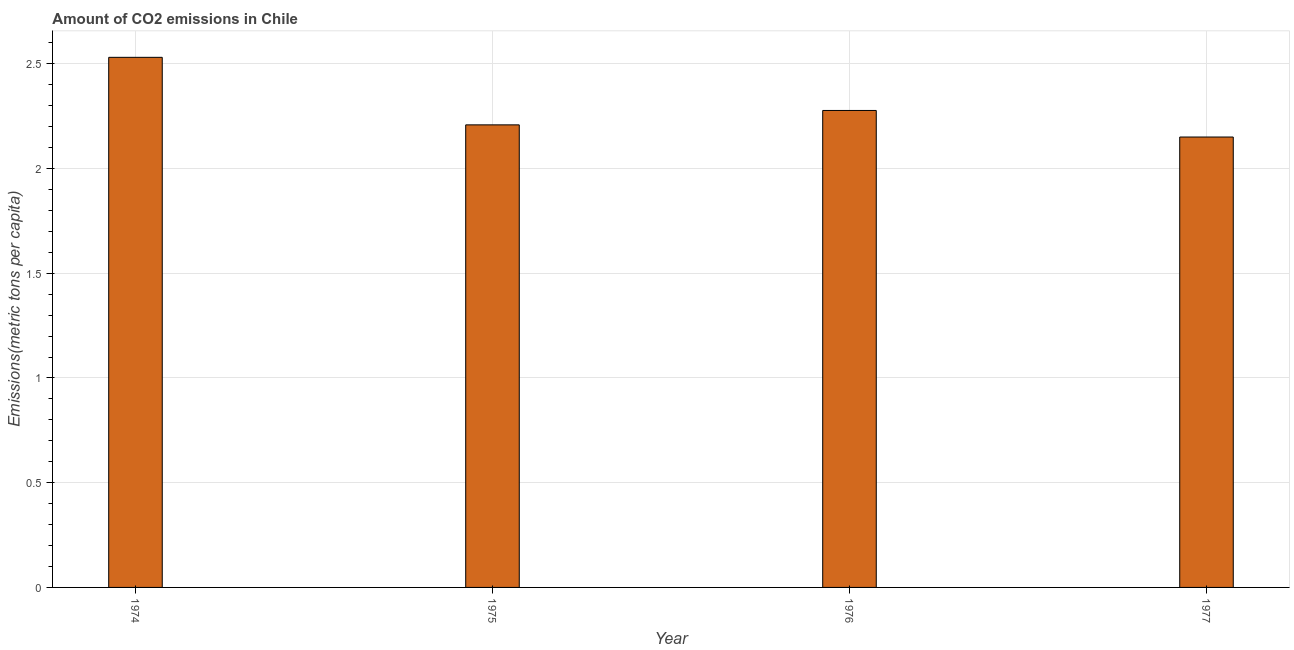Does the graph contain any zero values?
Offer a very short reply. No. What is the title of the graph?
Your response must be concise. Amount of CO2 emissions in Chile. What is the label or title of the Y-axis?
Keep it short and to the point. Emissions(metric tons per capita). What is the amount of co2 emissions in 1974?
Provide a succinct answer. 2.53. Across all years, what is the maximum amount of co2 emissions?
Your response must be concise. 2.53. Across all years, what is the minimum amount of co2 emissions?
Make the answer very short. 2.15. In which year was the amount of co2 emissions maximum?
Ensure brevity in your answer.  1974. In which year was the amount of co2 emissions minimum?
Provide a succinct answer. 1977. What is the sum of the amount of co2 emissions?
Provide a short and direct response. 9.17. What is the difference between the amount of co2 emissions in 1975 and 1977?
Offer a very short reply. 0.06. What is the average amount of co2 emissions per year?
Offer a very short reply. 2.29. What is the median amount of co2 emissions?
Your response must be concise. 2.24. In how many years, is the amount of co2 emissions greater than 0.5 metric tons per capita?
Your answer should be compact. 4. Do a majority of the years between 1977 and 1975 (inclusive) have amount of co2 emissions greater than 2.3 metric tons per capita?
Ensure brevity in your answer.  Yes. What is the ratio of the amount of co2 emissions in 1974 to that in 1976?
Keep it short and to the point. 1.11. Is the amount of co2 emissions in 1976 less than that in 1977?
Your response must be concise. No. What is the difference between the highest and the second highest amount of co2 emissions?
Offer a terse response. 0.25. Is the sum of the amount of co2 emissions in 1974 and 1977 greater than the maximum amount of co2 emissions across all years?
Give a very brief answer. Yes. What is the difference between the highest and the lowest amount of co2 emissions?
Give a very brief answer. 0.38. In how many years, is the amount of co2 emissions greater than the average amount of co2 emissions taken over all years?
Your answer should be compact. 1. How many bars are there?
Your answer should be compact. 4. Are all the bars in the graph horizontal?
Offer a terse response. No. What is the Emissions(metric tons per capita) in 1974?
Your answer should be very brief. 2.53. What is the Emissions(metric tons per capita) in 1975?
Your answer should be very brief. 2.21. What is the Emissions(metric tons per capita) in 1976?
Your response must be concise. 2.28. What is the Emissions(metric tons per capita) in 1977?
Give a very brief answer. 2.15. What is the difference between the Emissions(metric tons per capita) in 1974 and 1975?
Offer a terse response. 0.32. What is the difference between the Emissions(metric tons per capita) in 1974 and 1976?
Offer a very short reply. 0.25. What is the difference between the Emissions(metric tons per capita) in 1974 and 1977?
Make the answer very short. 0.38. What is the difference between the Emissions(metric tons per capita) in 1975 and 1976?
Offer a terse response. -0.07. What is the difference between the Emissions(metric tons per capita) in 1975 and 1977?
Keep it short and to the point. 0.06. What is the difference between the Emissions(metric tons per capita) in 1976 and 1977?
Ensure brevity in your answer.  0.13. What is the ratio of the Emissions(metric tons per capita) in 1974 to that in 1975?
Offer a very short reply. 1.15. What is the ratio of the Emissions(metric tons per capita) in 1974 to that in 1976?
Make the answer very short. 1.11. What is the ratio of the Emissions(metric tons per capita) in 1974 to that in 1977?
Ensure brevity in your answer.  1.18. What is the ratio of the Emissions(metric tons per capita) in 1975 to that in 1976?
Keep it short and to the point. 0.97. What is the ratio of the Emissions(metric tons per capita) in 1975 to that in 1977?
Offer a very short reply. 1.03. What is the ratio of the Emissions(metric tons per capita) in 1976 to that in 1977?
Provide a succinct answer. 1.06. 